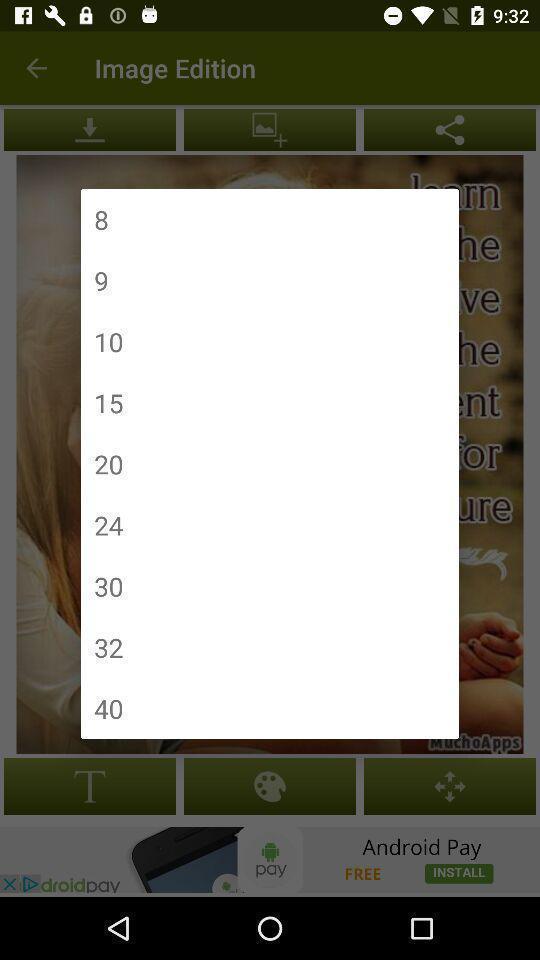Provide a description of this screenshot. Pop-up window showing list of numbers. 